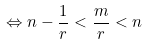Convert formula to latex. <formula><loc_0><loc_0><loc_500><loc_500>\Leftrightarrow n - \frac { 1 } { r } < \frac { m } { r } < n</formula> 